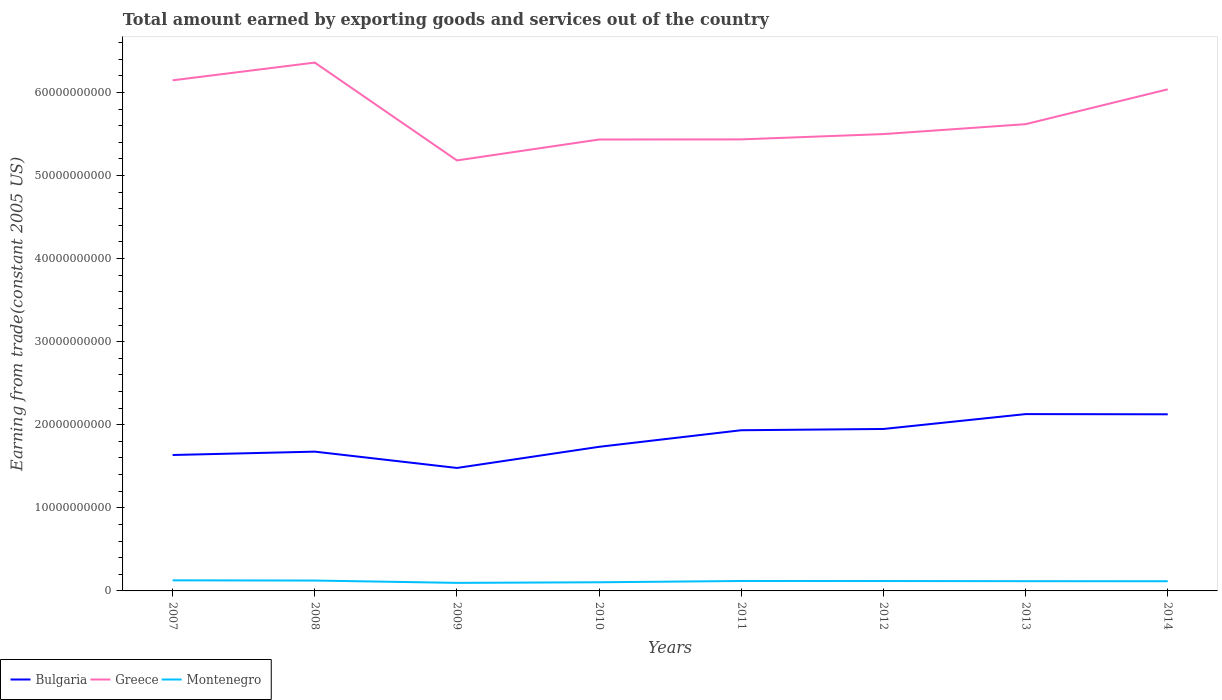Is the number of lines equal to the number of legend labels?
Provide a short and direct response. Yes. Across all years, what is the maximum total amount earned by exporting goods and services in Greece?
Your answer should be compact. 5.18e+1. In which year was the total amount earned by exporting goods and services in Bulgaria maximum?
Your response must be concise. 2009. What is the total total amount earned by exporting goods and services in Montenegro in the graph?
Keep it short and to the point. 2.61e+07. What is the difference between the highest and the second highest total amount earned by exporting goods and services in Greece?
Your answer should be very brief. 1.18e+1. Is the total amount earned by exporting goods and services in Montenegro strictly greater than the total amount earned by exporting goods and services in Greece over the years?
Provide a short and direct response. Yes. How many lines are there?
Ensure brevity in your answer.  3. How many years are there in the graph?
Your answer should be compact. 8. Are the values on the major ticks of Y-axis written in scientific E-notation?
Provide a succinct answer. No. Does the graph contain grids?
Keep it short and to the point. No. How many legend labels are there?
Offer a very short reply. 3. How are the legend labels stacked?
Your answer should be compact. Horizontal. What is the title of the graph?
Give a very brief answer. Total amount earned by exporting goods and services out of the country. What is the label or title of the X-axis?
Offer a terse response. Years. What is the label or title of the Y-axis?
Give a very brief answer. Earning from trade(constant 2005 US). What is the Earning from trade(constant 2005 US) in Bulgaria in 2007?
Ensure brevity in your answer.  1.64e+1. What is the Earning from trade(constant 2005 US) in Greece in 2007?
Keep it short and to the point. 6.15e+1. What is the Earning from trade(constant 2005 US) of Montenegro in 2007?
Ensure brevity in your answer.  1.27e+09. What is the Earning from trade(constant 2005 US) in Bulgaria in 2008?
Offer a terse response. 1.68e+1. What is the Earning from trade(constant 2005 US) of Greece in 2008?
Give a very brief answer. 6.36e+1. What is the Earning from trade(constant 2005 US) in Montenegro in 2008?
Your answer should be compact. 1.25e+09. What is the Earning from trade(constant 2005 US) in Bulgaria in 2009?
Provide a succinct answer. 1.48e+1. What is the Earning from trade(constant 2005 US) in Greece in 2009?
Offer a very short reply. 5.18e+1. What is the Earning from trade(constant 2005 US) in Montenegro in 2009?
Provide a short and direct response. 9.69e+08. What is the Earning from trade(constant 2005 US) of Bulgaria in 2010?
Provide a succinct answer. 1.73e+1. What is the Earning from trade(constant 2005 US) in Greece in 2010?
Your answer should be very brief. 5.43e+1. What is the Earning from trade(constant 2005 US) of Montenegro in 2010?
Ensure brevity in your answer.  1.04e+09. What is the Earning from trade(constant 2005 US) in Bulgaria in 2011?
Your answer should be compact. 1.93e+1. What is the Earning from trade(constant 2005 US) of Greece in 2011?
Your answer should be very brief. 5.44e+1. What is the Earning from trade(constant 2005 US) of Montenegro in 2011?
Your response must be concise. 1.19e+09. What is the Earning from trade(constant 2005 US) in Bulgaria in 2012?
Make the answer very short. 1.95e+1. What is the Earning from trade(constant 2005 US) in Greece in 2012?
Your answer should be very brief. 5.50e+1. What is the Earning from trade(constant 2005 US) in Montenegro in 2012?
Provide a succinct answer. 1.19e+09. What is the Earning from trade(constant 2005 US) in Bulgaria in 2013?
Keep it short and to the point. 2.13e+1. What is the Earning from trade(constant 2005 US) in Greece in 2013?
Offer a terse response. 5.62e+1. What is the Earning from trade(constant 2005 US) in Montenegro in 2013?
Your answer should be compact. 1.17e+09. What is the Earning from trade(constant 2005 US) of Bulgaria in 2014?
Provide a short and direct response. 2.13e+1. What is the Earning from trade(constant 2005 US) of Greece in 2014?
Keep it short and to the point. 6.04e+1. What is the Earning from trade(constant 2005 US) in Montenegro in 2014?
Your answer should be compact. 1.17e+09. Across all years, what is the maximum Earning from trade(constant 2005 US) in Bulgaria?
Provide a succinct answer. 2.13e+1. Across all years, what is the maximum Earning from trade(constant 2005 US) of Greece?
Your answer should be very brief. 6.36e+1. Across all years, what is the maximum Earning from trade(constant 2005 US) of Montenegro?
Provide a short and direct response. 1.27e+09. Across all years, what is the minimum Earning from trade(constant 2005 US) in Bulgaria?
Your response must be concise. 1.48e+1. Across all years, what is the minimum Earning from trade(constant 2005 US) in Greece?
Offer a very short reply. 5.18e+1. Across all years, what is the minimum Earning from trade(constant 2005 US) of Montenegro?
Your answer should be compact. 9.69e+08. What is the total Earning from trade(constant 2005 US) in Bulgaria in the graph?
Ensure brevity in your answer.  1.47e+11. What is the total Earning from trade(constant 2005 US) of Greece in the graph?
Keep it short and to the point. 4.57e+11. What is the total Earning from trade(constant 2005 US) of Montenegro in the graph?
Give a very brief answer. 9.26e+09. What is the difference between the Earning from trade(constant 2005 US) in Bulgaria in 2007 and that in 2008?
Your response must be concise. -4.05e+08. What is the difference between the Earning from trade(constant 2005 US) of Greece in 2007 and that in 2008?
Ensure brevity in your answer.  -2.13e+09. What is the difference between the Earning from trade(constant 2005 US) in Montenegro in 2007 and that in 2008?
Ensure brevity in your answer.  2.61e+07. What is the difference between the Earning from trade(constant 2005 US) in Bulgaria in 2007 and that in 2009?
Provide a succinct answer. 1.56e+09. What is the difference between the Earning from trade(constant 2005 US) of Greece in 2007 and that in 2009?
Make the answer very short. 9.64e+09. What is the difference between the Earning from trade(constant 2005 US) in Montenegro in 2007 and that in 2009?
Your answer should be compact. 3.05e+08. What is the difference between the Earning from trade(constant 2005 US) in Bulgaria in 2007 and that in 2010?
Provide a short and direct response. -9.86e+08. What is the difference between the Earning from trade(constant 2005 US) in Greece in 2007 and that in 2010?
Your answer should be very brief. 7.12e+09. What is the difference between the Earning from trade(constant 2005 US) in Montenegro in 2007 and that in 2010?
Your answer should be very brief. 2.32e+08. What is the difference between the Earning from trade(constant 2005 US) in Bulgaria in 2007 and that in 2011?
Give a very brief answer. -2.98e+09. What is the difference between the Earning from trade(constant 2005 US) of Greece in 2007 and that in 2011?
Provide a succinct answer. 7.11e+09. What is the difference between the Earning from trade(constant 2005 US) in Montenegro in 2007 and that in 2011?
Provide a short and direct response. 8.01e+07. What is the difference between the Earning from trade(constant 2005 US) of Bulgaria in 2007 and that in 2012?
Offer a very short reply. -3.13e+09. What is the difference between the Earning from trade(constant 2005 US) of Greece in 2007 and that in 2012?
Offer a terse response. 6.47e+09. What is the difference between the Earning from trade(constant 2005 US) in Montenegro in 2007 and that in 2012?
Offer a terse response. 8.41e+07. What is the difference between the Earning from trade(constant 2005 US) in Bulgaria in 2007 and that in 2013?
Your response must be concise. -4.92e+09. What is the difference between the Earning from trade(constant 2005 US) in Greece in 2007 and that in 2013?
Your answer should be very brief. 5.28e+09. What is the difference between the Earning from trade(constant 2005 US) of Montenegro in 2007 and that in 2013?
Your answer should be compact. 1.00e+08. What is the difference between the Earning from trade(constant 2005 US) of Bulgaria in 2007 and that in 2014?
Give a very brief answer. -4.90e+09. What is the difference between the Earning from trade(constant 2005 US) in Greece in 2007 and that in 2014?
Your answer should be compact. 1.08e+09. What is the difference between the Earning from trade(constant 2005 US) in Montenegro in 2007 and that in 2014?
Offer a terse response. 1.08e+08. What is the difference between the Earning from trade(constant 2005 US) of Bulgaria in 2008 and that in 2009?
Offer a terse response. 1.96e+09. What is the difference between the Earning from trade(constant 2005 US) of Greece in 2008 and that in 2009?
Provide a succinct answer. 1.18e+1. What is the difference between the Earning from trade(constant 2005 US) in Montenegro in 2008 and that in 2009?
Make the answer very short. 2.79e+08. What is the difference between the Earning from trade(constant 2005 US) of Bulgaria in 2008 and that in 2010?
Your answer should be compact. -5.80e+08. What is the difference between the Earning from trade(constant 2005 US) of Greece in 2008 and that in 2010?
Provide a succinct answer. 9.26e+09. What is the difference between the Earning from trade(constant 2005 US) in Montenegro in 2008 and that in 2010?
Your answer should be very brief. 2.06e+08. What is the difference between the Earning from trade(constant 2005 US) of Bulgaria in 2008 and that in 2011?
Keep it short and to the point. -2.58e+09. What is the difference between the Earning from trade(constant 2005 US) of Greece in 2008 and that in 2011?
Give a very brief answer. 9.24e+09. What is the difference between the Earning from trade(constant 2005 US) in Montenegro in 2008 and that in 2011?
Ensure brevity in your answer.  5.40e+07. What is the difference between the Earning from trade(constant 2005 US) of Bulgaria in 2008 and that in 2012?
Provide a short and direct response. -2.73e+09. What is the difference between the Earning from trade(constant 2005 US) of Greece in 2008 and that in 2012?
Your answer should be very brief. 8.61e+09. What is the difference between the Earning from trade(constant 2005 US) in Montenegro in 2008 and that in 2012?
Make the answer very short. 5.80e+07. What is the difference between the Earning from trade(constant 2005 US) in Bulgaria in 2008 and that in 2013?
Provide a succinct answer. -4.52e+09. What is the difference between the Earning from trade(constant 2005 US) in Greece in 2008 and that in 2013?
Offer a terse response. 7.41e+09. What is the difference between the Earning from trade(constant 2005 US) in Montenegro in 2008 and that in 2013?
Your answer should be very brief. 7.40e+07. What is the difference between the Earning from trade(constant 2005 US) in Bulgaria in 2008 and that in 2014?
Provide a succinct answer. -4.49e+09. What is the difference between the Earning from trade(constant 2005 US) in Greece in 2008 and that in 2014?
Keep it short and to the point. 3.22e+09. What is the difference between the Earning from trade(constant 2005 US) of Montenegro in 2008 and that in 2014?
Offer a very short reply. 8.24e+07. What is the difference between the Earning from trade(constant 2005 US) of Bulgaria in 2009 and that in 2010?
Provide a short and direct response. -2.54e+09. What is the difference between the Earning from trade(constant 2005 US) in Greece in 2009 and that in 2010?
Provide a short and direct response. -2.52e+09. What is the difference between the Earning from trade(constant 2005 US) in Montenegro in 2009 and that in 2010?
Give a very brief answer. -7.26e+07. What is the difference between the Earning from trade(constant 2005 US) of Bulgaria in 2009 and that in 2011?
Make the answer very short. -4.54e+09. What is the difference between the Earning from trade(constant 2005 US) of Greece in 2009 and that in 2011?
Make the answer very short. -2.53e+09. What is the difference between the Earning from trade(constant 2005 US) of Montenegro in 2009 and that in 2011?
Ensure brevity in your answer.  -2.25e+08. What is the difference between the Earning from trade(constant 2005 US) of Bulgaria in 2009 and that in 2012?
Keep it short and to the point. -4.69e+09. What is the difference between the Earning from trade(constant 2005 US) of Greece in 2009 and that in 2012?
Ensure brevity in your answer.  -3.17e+09. What is the difference between the Earning from trade(constant 2005 US) of Montenegro in 2009 and that in 2012?
Offer a terse response. -2.21e+08. What is the difference between the Earning from trade(constant 2005 US) in Bulgaria in 2009 and that in 2013?
Make the answer very short. -6.48e+09. What is the difference between the Earning from trade(constant 2005 US) of Greece in 2009 and that in 2013?
Keep it short and to the point. -4.36e+09. What is the difference between the Earning from trade(constant 2005 US) of Montenegro in 2009 and that in 2013?
Provide a short and direct response. -2.05e+08. What is the difference between the Earning from trade(constant 2005 US) in Bulgaria in 2009 and that in 2014?
Your response must be concise. -6.46e+09. What is the difference between the Earning from trade(constant 2005 US) of Greece in 2009 and that in 2014?
Provide a succinct answer. -8.56e+09. What is the difference between the Earning from trade(constant 2005 US) of Montenegro in 2009 and that in 2014?
Your response must be concise. -1.97e+08. What is the difference between the Earning from trade(constant 2005 US) in Bulgaria in 2010 and that in 2011?
Ensure brevity in your answer.  -2.00e+09. What is the difference between the Earning from trade(constant 2005 US) of Greece in 2010 and that in 2011?
Your response must be concise. -1.48e+07. What is the difference between the Earning from trade(constant 2005 US) of Montenegro in 2010 and that in 2011?
Your response must be concise. -1.52e+08. What is the difference between the Earning from trade(constant 2005 US) of Bulgaria in 2010 and that in 2012?
Keep it short and to the point. -2.15e+09. What is the difference between the Earning from trade(constant 2005 US) in Greece in 2010 and that in 2012?
Your answer should be very brief. -6.52e+08. What is the difference between the Earning from trade(constant 2005 US) of Montenegro in 2010 and that in 2012?
Your response must be concise. -1.48e+08. What is the difference between the Earning from trade(constant 2005 US) in Bulgaria in 2010 and that in 2013?
Your response must be concise. -3.94e+09. What is the difference between the Earning from trade(constant 2005 US) in Greece in 2010 and that in 2013?
Give a very brief answer. -1.85e+09. What is the difference between the Earning from trade(constant 2005 US) in Montenegro in 2010 and that in 2013?
Make the answer very short. -1.32e+08. What is the difference between the Earning from trade(constant 2005 US) of Bulgaria in 2010 and that in 2014?
Provide a succinct answer. -3.91e+09. What is the difference between the Earning from trade(constant 2005 US) of Greece in 2010 and that in 2014?
Offer a very short reply. -6.04e+09. What is the difference between the Earning from trade(constant 2005 US) of Montenegro in 2010 and that in 2014?
Your answer should be very brief. -1.24e+08. What is the difference between the Earning from trade(constant 2005 US) of Bulgaria in 2011 and that in 2012?
Your answer should be very brief. -1.51e+08. What is the difference between the Earning from trade(constant 2005 US) of Greece in 2011 and that in 2012?
Offer a terse response. -6.38e+08. What is the difference between the Earning from trade(constant 2005 US) of Montenegro in 2011 and that in 2012?
Offer a very short reply. 4.06e+06. What is the difference between the Earning from trade(constant 2005 US) of Bulgaria in 2011 and that in 2013?
Give a very brief answer. -1.94e+09. What is the difference between the Earning from trade(constant 2005 US) in Greece in 2011 and that in 2013?
Provide a short and direct response. -1.83e+09. What is the difference between the Earning from trade(constant 2005 US) in Montenegro in 2011 and that in 2013?
Your answer should be very brief. 2.00e+07. What is the difference between the Earning from trade(constant 2005 US) in Bulgaria in 2011 and that in 2014?
Your answer should be very brief. -1.92e+09. What is the difference between the Earning from trade(constant 2005 US) in Greece in 2011 and that in 2014?
Keep it short and to the point. -6.02e+09. What is the difference between the Earning from trade(constant 2005 US) in Montenegro in 2011 and that in 2014?
Your answer should be compact. 2.84e+07. What is the difference between the Earning from trade(constant 2005 US) of Bulgaria in 2012 and that in 2013?
Your response must be concise. -1.79e+09. What is the difference between the Earning from trade(constant 2005 US) in Greece in 2012 and that in 2013?
Give a very brief answer. -1.19e+09. What is the difference between the Earning from trade(constant 2005 US) of Montenegro in 2012 and that in 2013?
Keep it short and to the point. 1.59e+07. What is the difference between the Earning from trade(constant 2005 US) of Bulgaria in 2012 and that in 2014?
Make the answer very short. -1.77e+09. What is the difference between the Earning from trade(constant 2005 US) in Greece in 2012 and that in 2014?
Ensure brevity in your answer.  -5.39e+09. What is the difference between the Earning from trade(constant 2005 US) in Montenegro in 2012 and that in 2014?
Offer a very short reply. 2.43e+07. What is the difference between the Earning from trade(constant 2005 US) of Bulgaria in 2013 and that in 2014?
Provide a succinct answer. 2.37e+07. What is the difference between the Earning from trade(constant 2005 US) of Greece in 2013 and that in 2014?
Give a very brief answer. -4.19e+09. What is the difference between the Earning from trade(constant 2005 US) of Montenegro in 2013 and that in 2014?
Offer a very short reply. 8.40e+06. What is the difference between the Earning from trade(constant 2005 US) of Bulgaria in 2007 and the Earning from trade(constant 2005 US) of Greece in 2008?
Offer a terse response. -4.72e+1. What is the difference between the Earning from trade(constant 2005 US) in Bulgaria in 2007 and the Earning from trade(constant 2005 US) in Montenegro in 2008?
Keep it short and to the point. 1.51e+1. What is the difference between the Earning from trade(constant 2005 US) in Greece in 2007 and the Earning from trade(constant 2005 US) in Montenegro in 2008?
Keep it short and to the point. 6.02e+1. What is the difference between the Earning from trade(constant 2005 US) of Bulgaria in 2007 and the Earning from trade(constant 2005 US) of Greece in 2009?
Keep it short and to the point. -3.55e+1. What is the difference between the Earning from trade(constant 2005 US) of Bulgaria in 2007 and the Earning from trade(constant 2005 US) of Montenegro in 2009?
Ensure brevity in your answer.  1.54e+1. What is the difference between the Earning from trade(constant 2005 US) in Greece in 2007 and the Earning from trade(constant 2005 US) in Montenegro in 2009?
Ensure brevity in your answer.  6.05e+1. What is the difference between the Earning from trade(constant 2005 US) in Bulgaria in 2007 and the Earning from trade(constant 2005 US) in Greece in 2010?
Provide a succinct answer. -3.80e+1. What is the difference between the Earning from trade(constant 2005 US) of Bulgaria in 2007 and the Earning from trade(constant 2005 US) of Montenegro in 2010?
Keep it short and to the point. 1.53e+1. What is the difference between the Earning from trade(constant 2005 US) of Greece in 2007 and the Earning from trade(constant 2005 US) of Montenegro in 2010?
Your answer should be compact. 6.04e+1. What is the difference between the Earning from trade(constant 2005 US) in Bulgaria in 2007 and the Earning from trade(constant 2005 US) in Greece in 2011?
Offer a very short reply. -3.80e+1. What is the difference between the Earning from trade(constant 2005 US) of Bulgaria in 2007 and the Earning from trade(constant 2005 US) of Montenegro in 2011?
Provide a short and direct response. 1.52e+1. What is the difference between the Earning from trade(constant 2005 US) of Greece in 2007 and the Earning from trade(constant 2005 US) of Montenegro in 2011?
Your response must be concise. 6.03e+1. What is the difference between the Earning from trade(constant 2005 US) in Bulgaria in 2007 and the Earning from trade(constant 2005 US) in Greece in 2012?
Your answer should be compact. -3.86e+1. What is the difference between the Earning from trade(constant 2005 US) in Bulgaria in 2007 and the Earning from trade(constant 2005 US) in Montenegro in 2012?
Your answer should be compact. 1.52e+1. What is the difference between the Earning from trade(constant 2005 US) in Greece in 2007 and the Earning from trade(constant 2005 US) in Montenegro in 2012?
Your answer should be very brief. 6.03e+1. What is the difference between the Earning from trade(constant 2005 US) of Bulgaria in 2007 and the Earning from trade(constant 2005 US) of Greece in 2013?
Offer a terse response. -3.98e+1. What is the difference between the Earning from trade(constant 2005 US) of Bulgaria in 2007 and the Earning from trade(constant 2005 US) of Montenegro in 2013?
Provide a short and direct response. 1.52e+1. What is the difference between the Earning from trade(constant 2005 US) in Greece in 2007 and the Earning from trade(constant 2005 US) in Montenegro in 2013?
Offer a terse response. 6.03e+1. What is the difference between the Earning from trade(constant 2005 US) in Bulgaria in 2007 and the Earning from trade(constant 2005 US) in Greece in 2014?
Provide a short and direct response. -4.40e+1. What is the difference between the Earning from trade(constant 2005 US) in Bulgaria in 2007 and the Earning from trade(constant 2005 US) in Montenegro in 2014?
Provide a short and direct response. 1.52e+1. What is the difference between the Earning from trade(constant 2005 US) in Greece in 2007 and the Earning from trade(constant 2005 US) in Montenegro in 2014?
Ensure brevity in your answer.  6.03e+1. What is the difference between the Earning from trade(constant 2005 US) of Bulgaria in 2008 and the Earning from trade(constant 2005 US) of Greece in 2009?
Keep it short and to the point. -3.51e+1. What is the difference between the Earning from trade(constant 2005 US) of Bulgaria in 2008 and the Earning from trade(constant 2005 US) of Montenegro in 2009?
Keep it short and to the point. 1.58e+1. What is the difference between the Earning from trade(constant 2005 US) of Greece in 2008 and the Earning from trade(constant 2005 US) of Montenegro in 2009?
Your response must be concise. 6.26e+1. What is the difference between the Earning from trade(constant 2005 US) in Bulgaria in 2008 and the Earning from trade(constant 2005 US) in Greece in 2010?
Give a very brief answer. -3.76e+1. What is the difference between the Earning from trade(constant 2005 US) in Bulgaria in 2008 and the Earning from trade(constant 2005 US) in Montenegro in 2010?
Ensure brevity in your answer.  1.57e+1. What is the difference between the Earning from trade(constant 2005 US) in Greece in 2008 and the Earning from trade(constant 2005 US) in Montenegro in 2010?
Offer a very short reply. 6.26e+1. What is the difference between the Earning from trade(constant 2005 US) in Bulgaria in 2008 and the Earning from trade(constant 2005 US) in Greece in 2011?
Your answer should be very brief. -3.76e+1. What is the difference between the Earning from trade(constant 2005 US) in Bulgaria in 2008 and the Earning from trade(constant 2005 US) in Montenegro in 2011?
Offer a terse response. 1.56e+1. What is the difference between the Earning from trade(constant 2005 US) in Greece in 2008 and the Earning from trade(constant 2005 US) in Montenegro in 2011?
Make the answer very short. 6.24e+1. What is the difference between the Earning from trade(constant 2005 US) in Bulgaria in 2008 and the Earning from trade(constant 2005 US) in Greece in 2012?
Provide a short and direct response. -3.82e+1. What is the difference between the Earning from trade(constant 2005 US) of Bulgaria in 2008 and the Earning from trade(constant 2005 US) of Montenegro in 2012?
Make the answer very short. 1.56e+1. What is the difference between the Earning from trade(constant 2005 US) of Greece in 2008 and the Earning from trade(constant 2005 US) of Montenegro in 2012?
Offer a very short reply. 6.24e+1. What is the difference between the Earning from trade(constant 2005 US) of Bulgaria in 2008 and the Earning from trade(constant 2005 US) of Greece in 2013?
Provide a short and direct response. -3.94e+1. What is the difference between the Earning from trade(constant 2005 US) in Bulgaria in 2008 and the Earning from trade(constant 2005 US) in Montenegro in 2013?
Ensure brevity in your answer.  1.56e+1. What is the difference between the Earning from trade(constant 2005 US) in Greece in 2008 and the Earning from trade(constant 2005 US) in Montenegro in 2013?
Your response must be concise. 6.24e+1. What is the difference between the Earning from trade(constant 2005 US) in Bulgaria in 2008 and the Earning from trade(constant 2005 US) in Greece in 2014?
Keep it short and to the point. -4.36e+1. What is the difference between the Earning from trade(constant 2005 US) of Bulgaria in 2008 and the Earning from trade(constant 2005 US) of Montenegro in 2014?
Your answer should be compact. 1.56e+1. What is the difference between the Earning from trade(constant 2005 US) in Greece in 2008 and the Earning from trade(constant 2005 US) in Montenegro in 2014?
Offer a terse response. 6.24e+1. What is the difference between the Earning from trade(constant 2005 US) in Bulgaria in 2009 and the Earning from trade(constant 2005 US) in Greece in 2010?
Keep it short and to the point. -3.95e+1. What is the difference between the Earning from trade(constant 2005 US) in Bulgaria in 2009 and the Earning from trade(constant 2005 US) in Montenegro in 2010?
Make the answer very short. 1.38e+1. What is the difference between the Earning from trade(constant 2005 US) of Greece in 2009 and the Earning from trade(constant 2005 US) of Montenegro in 2010?
Keep it short and to the point. 5.08e+1. What is the difference between the Earning from trade(constant 2005 US) in Bulgaria in 2009 and the Earning from trade(constant 2005 US) in Greece in 2011?
Provide a short and direct response. -3.95e+1. What is the difference between the Earning from trade(constant 2005 US) in Bulgaria in 2009 and the Earning from trade(constant 2005 US) in Montenegro in 2011?
Offer a terse response. 1.36e+1. What is the difference between the Earning from trade(constant 2005 US) of Greece in 2009 and the Earning from trade(constant 2005 US) of Montenegro in 2011?
Your response must be concise. 5.06e+1. What is the difference between the Earning from trade(constant 2005 US) of Bulgaria in 2009 and the Earning from trade(constant 2005 US) of Greece in 2012?
Offer a terse response. -4.02e+1. What is the difference between the Earning from trade(constant 2005 US) of Bulgaria in 2009 and the Earning from trade(constant 2005 US) of Montenegro in 2012?
Your answer should be very brief. 1.36e+1. What is the difference between the Earning from trade(constant 2005 US) of Greece in 2009 and the Earning from trade(constant 2005 US) of Montenegro in 2012?
Your response must be concise. 5.06e+1. What is the difference between the Earning from trade(constant 2005 US) in Bulgaria in 2009 and the Earning from trade(constant 2005 US) in Greece in 2013?
Make the answer very short. -4.14e+1. What is the difference between the Earning from trade(constant 2005 US) in Bulgaria in 2009 and the Earning from trade(constant 2005 US) in Montenegro in 2013?
Make the answer very short. 1.36e+1. What is the difference between the Earning from trade(constant 2005 US) in Greece in 2009 and the Earning from trade(constant 2005 US) in Montenegro in 2013?
Offer a very short reply. 5.06e+1. What is the difference between the Earning from trade(constant 2005 US) in Bulgaria in 2009 and the Earning from trade(constant 2005 US) in Greece in 2014?
Offer a very short reply. -4.56e+1. What is the difference between the Earning from trade(constant 2005 US) of Bulgaria in 2009 and the Earning from trade(constant 2005 US) of Montenegro in 2014?
Your response must be concise. 1.36e+1. What is the difference between the Earning from trade(constant 2005 US) in Greece in 2009 and the Earning from trade(constant 2005 US) in Montenegro in 2014?
Keep it short and to the point. 5.07e+1. What is the difference between the Earning from trade(constant 2005 US) of Bulgaria in 2010 and the Earning from trade(constant 2005 US) of Greece in 2011?
Provide a short and direct response. -3.70e+1. What is the difference between the Earning from trade(constant 2005 US) in Bulgaria in 2010 and the Earning from trade(constant 2005 US) in Montenegro in 2011?
Your answer should be very brief. 1.62e+1. What is the difference between the Earning from trade(constant 2005 US) in Greece in 2010 and the Earning from trade(constant 2005 US) in Montenegro in 2011?
Offer a terse response. 5.31e+1. What is the difference between the Earning from trade(constant 2005 US) in Bulgaria in 2010 and the Earning from trade(constant 2005 US) in Greece in 2012?
Ensure brevity in your answer.  -3.76e+1. What is the difference between the Earning from trade(constant 2005 US) of Bulgaria in 2010 and the Earning from trade(constant 2005 US) of Montenegro in 2012?
Ensure brevity in your answer.  1.62e+1. What is the difference between the Earning from trade(constant 2005 US) in Greece in 2010 and the Earning from trade(constant 2005 US) in Montenegro in 2012?
Your response must be concise. 5.31e+1. What is the difference between the Earning from trade(constant 2005 US) in Bulgaria in 2010 and the Earning from trade(constant 2005 US) in Greece in 2013?
Your response must be concise. -3.88e+1. What is the difference between the Earning from trade(constant 2005 US) in Bulgaria in 2010 and the Earning from trade(constant 2005 US) in Montenegro in 2013?
Offer a very short reply. 1.62e+1. What is the difference between the Earning from trade(constant 2005 US) in Greece in 2010 and the Earning from trade(constant 2005 US) in Montenegro in 2013?
Your response must be concise. 5.32e+1. What is the difference between the Earning from trade(constant 2005 US) of Bulgaria in 2010 and the Earning from trade(constant 2005 US) of Greece in 2014?
Provide a short and direct response. -4.30e+1. What is the difference between the Earning from trade(constant 2005 US) in Bulgaria in 2010 and the Earning from trade(constant 2005 US) in Montenegro in 2014?
Make the answer very short. 1.62e+1. What is the difference between the Earning from trade(constant 2005 US) in Greece in 2010 and the Earning from trade(constant 2005 US) in Montenegro in 2014?
Keep it short and to the point. 5.32e+1. What is the difference between the Earning from trade(constant 2005 US) in Bulgaria in 2011 and the Earning from trade(constant 2005 US) in Greece in 2012?
Keep it short and to the point. -3.56e+1. What is the difference between the Earning from trade(constant 2005 US) of Bulgaria in 2011 and the Earning from trade(constant 2005 US) of Montenegro in 2012?
Offer a very short reply. 1.82e+1. What is the difference between the Earning from trade(constant 2005 US) of Greece in 2011 and the Earning from trade(constant 2005 US) of Montenegro in 2012?
Offer a very short reply. 5.32e+1. What is the difference between the Earning from trade(constant 2005 US) of Bulgaria in 2011 and the Earning from trade(constant 2005 US) of Greece in 2013?
Your response must be concise. -3.68e+1. What is the difference between the Earning from trade(constant 2005 US) of Bulgaria in 2011 and the Earning from trade(constant 2005 US) of Montenegro in 2013?
Offer a terse response. 1.82e+1. What is the difference between the Earning from trade(constant 2005 US) in Greece in 2011 and the Earning from trade(constant 2005 US) in Montenegro in 2013?
Your response must be concise. 5.32e+1. What is the difference between the Earning from trade(constant 2005 US) in Bulgaria in 2011 and the Earning from trade(constant 2005 US) in Greece in 2014?
Provide a succinct answer. -4.10e+1. What is the difference between the Earning from trade(constant 2005 US) in Bulgaria in 2011 and the Earning from trade(constant 2005 US) in Montenegro in 2014?
Offer a very short reply. 1.82e+1. What is the difference between the Earning from trade(constant 2005 US) in Greece in 2011 and the Earning from trade(constant 2005 US) in Montenegro in 2014?
Provide a short and direct response. 5.32e+1. What is the difference between the Earning from trade(constant 2005 US) in Bulgaria in 2012 and the Earning from trade(constant 2005 US) in Greece in 2013?
Give a very brief answer. -3.67e+1. What is the difference between the Earning from trade(constant 2005 US) of Bulgaria in 2012 and the Earning from trade(constant 2005 US) of Montenegro in 2013?
Keep it short and to the point. 1.83e+1. What is the difference between the Earning from trade(constant 2005 US) of Greece in 2012 and the Earning from trade(constant 2005 US) of Montenegro in 2013?
Ensure brevity in your answer.  5.38e+1. What is the difference between the Earning from trade(constant 2005 US) of Bulgaria in 2012 and the Earning from trade(constant 2005 US) of Greece in 2014?
Offer a terse response. -4.09e+1. What is the difference between the Earning from trade(constant 2005 US) of Bulgaria in 2012 and the Earning from trade(constant 2005 US) of Montenegro in 2014?
Your response must be concise. 1.83e+1. What is the difference between the Earning from trade(constant 2005 US) of Greece in 2012 and the Earning from trade(constant 2005 US) of Montenegro in 2014?
Ensure brevity in your answer.  5.38e+1. What is the difference between the Earning from trade(constant 2005 US) of Bulgaria in 2013 and the Earning from trade(constant 2005 US) of Greece in 2014?
Your answer should be compact. -3.91e+1. What is the difference between the Earning from trade(constant 2005 US) of Bulgaria in 2013 and the Earning from trade(constant 2005 US) of Montenegro in 2014?
Provide a short and direct response. 2.01e+1. What is the difference between the Earning from trade(constant 2005 US) of Greece in 2013 and the Earning from trade(constant 2005 US) of Montenegro in 2014?
Offer a very short reply. 5.50e+1. What is the average Earning from trade(constant 2005 US) of Bulgaria per year?
Provide a succinct answer. 1.83e+1. What is the average Earning from trade(constant 2005 US) of Greece per year?
Your response must be concise. 5.71e+1. What is the average Earning from trade(constant 2005 US) of Montenegro per year?
Keep it short and to the point. 1.16e+09. In the year 2007, what is the difference between the Earning from trade(constant 2005 US) of Bulgaria and Earning from trade(constant 2005 US) of Greece?
Keep it short and to the point. -4.51e+1. In the year 2007, what is the difference between the Earning from trade(constant 2005 US) of Bulgaria and Earning from trade(constant 2005 US) of Montenegro?
Give a very brief answer. 1.51e+1. In the year 2007, what is the difference between the Earning from trade(constant 2005 US) of Greece and Earning from trade(constant 2005 US) of Montenegro?
Provide a short and direct response. 6.02e+1. In the year 2008, what is the difference between the Earning from trade(constant 2005 US) in Bulgaria and Earning from trade(constant 2005 US) in Greece?
Keep it short and to the point. -4.68e+1. In the year 2008, what is the difference between the Earning from trade(constant 2005 US) of Bulgaria and Earning from trade(constant 2005 US) of Montenegro?
Your response must be concise. 1.55e+1. In the year 2008, what is the difference between the Earning from trade(constant 2005 US) of Greece and Earning from trade(constant 2005 US) of Montenegro?
Give a very brief answer. 6.23e+1. In the year 2009, what is the difference between the Earning from trade(constant 2005 US) of Bulgaria and Earning from trade(constant 2005 US) of Greece?
Ensure brevity in your answer.  -3.70e+1. In the year 2009, what is the difference between the Earning from trade(constant 2005 US) in Bulgaria and Earning from trade(constant 2005 US) in Montenegro?
Your response must be concise. 1.38e+1. In the year 2009, what is the difference between the Earning from trade(constant 2005 US) in Greece and Earning from trade(constant 2005 US) in Montenegro?
Your answer should be very brief. 5.08e+1. In the year 2010, what is the difference between the Earning from trade(constant 2005 US) in Bulgaria and Earning from trade(constant 2005 US) in Greece?
Provide a short and direct response. -3.70e+1. In the year 2010, what is the difference between the Earning from trade(constant 2005 US) of Bulgaria and Earning from trade(constant 2005 US) of Montenegro?
Offer a terse response. 1.63e+1. In the year 2010, what is the difference between the Earning from trade(constant 2005 US) in Greece and Earning from trade(constant 2005 US) in Montenegro?
Your answer should be very brief. 5.33e+1. In the year 2011, what is the difference between the Earning from trade(constant 2005 US) of Bulgaria and Earning from trade(constant 2005 US) of Greece?
Offer a very short reply. -3.50e+1. In the year 2011, what is the difference between the Earning from trade(constant 2005 US) of Bulgaria and Earning from trade(constant 2005 US) of Montenegro?
Give a very brief answer. 1.81e+1. In the year 2011, what is the difference between the Earning from trade(constant 2005 US) of Greece and Earning from trade(constant 2005 US) of Montenegro?
Provide a short and direct response. 5.32e+1. In the year 2012, what is the difference between the Earning from trade(constant 2005 US) of Bulgaria and Earning from trade(constant 2005 US) of Greece?
Provide a succinct answer. -3.55e+1. In the year 2012, what is the difference between the Earning from trade(constant 2005 US) of Bulgaria and Earning from trade(constant 2005 US) of Montenegro?
Provide a succinct answer. 1.83e+1. In the year 2012, what is the difference between the Earning from trade(constant 2005 US) in Greece and Earning from trade(constant 2005 US) in Montenegro?
Ensure brevity in your answer.  5.38e+1. In the year 2013, what is the difference between the Earning from trade(constant 2005 US) in Bulgaria and Earning from trade(constant 2005 US) in Greece?
Keep it short and to the point. -3.49e+1. In the year 2013, what is the difference between the Earning from trade(constant 2005 US) in Bulgaria and Earning from trade(constant 2005 US) in Montenegro?
Offer a very short reply. 2.01e+1. In the year 2013, what is the difference between the Earning from trade(constant 2005 US) in Greece and Earning from trade(constant 2005 US) in Montenegro?
Offer a very short reply. 5.50e+1. In the year 2014, what is the difference between the Earning from trade(constant 2005 US) of Bulgaria and Earning from trade(constant 2005 US) of Greece?
Make the answer very short. -3.91e+1. In the year 2014, what is the difference between the Earning from trade(constant 2005 US) of Bulgaria and Earning from trade(constant 2005 US) of Montenegro?
Your answer should be compact. 2.01e+1. In the year 2014, what is the difference between the Earning from trade(constant 2005 US) of Greece and Earning from trade(constant 2005 US) of Montenegro?
Offer a terse response. 5.92e+1. What is the ratio of the Earning from trade(constant 2005 US) of Bulgaria in 2007 to that in 2008?
Offer a very short reply. 0.98. What is the ratio of the Earning from trade(constant 2005 US) in Greece in 2007 to that in 2008?
Provide a succinct answer. 0.97. What is the ratio of the Earning from trade(constant 2005 US) in Montenegro in 2007 to that in 2008?
Your answer should be very brief. 1.02. What is the ratio of the Earning from trade(constant 2005 US) of Bulgaria in 2007 to that in 2009?
Your answer should be compact. 1.11. What is the ratio of the Earning from trade(constant 2005 US) in Greece in 2007 to that in 2009?
Provide a short and direct response. 1.19. What is the ratio of the Earning from trade(constant 2005 US) in Montenegro in 2007 to that in 2009?
Give a very brief answer. 1.31. What is the ratio of the Earning from trade(constant 2005 US) of Bulgaria in 2007 to that in 2010?
Ensure brevity in your answer.  0.94. What is the ratio of the Earning from trade(constant 2005 US) of Greece in 2007 to that in 2010?
Provide a short and direct response. 1.13. What is the ratio of the Earning from trade(constant 2005 US) of Montenegro in 2007 to that in 2010?
Make the answer very short. 1.22. What is the ratio of the Earning from trade(constant 2005 US) of Bulgaria in 2007 to that in 2011?
Keep it short and to the point. 0.85. What is the ratio of the Earning from trade(constant 2005 US) of Greece in 2007 to that in 2011?
Provide a succinct answer. 1.13. What is the ratio of the Earning from trade(constant 2005 US) in Montenegro in 2007 to that in 2011?
Your response must be concise. 1.07. What is the ratio of the Earning from trade(constant 2005 US) in Bulgaria in 2007 to that in 2012?
Give a very brief answer. 0.84. What is the ratio of the Earning from trade(constant 2005 US) in Greece in 2007 to that in 2012?
Your response must be concise. 1.12. What is the ratio of the Earning from trade(constant 2005 US) in Montenegro in 2007 to that in 2012?
Offer a very short reply. 1.07. What is the ratio of the Earning from trade(constant 2005 US) of Bulgaria in 2007 to that in 2013?
Give a very brief answer. 0.77. What is the ratio of the Earning from trade(constant 2005 US) in Greece in 2007 to that in 2013?
Your answer should be very brief. 1.09. What is the ratio of the Earning from trade(constant 2005 US) in Montenegro in 2007 to that in 2013?
Provide a succinct answer. 1.09. What is the ratio of the Earning from trade(constant 2005 US) of Bulgaria in 2007 to that in 2014?
Offer a very short reply. 0.77. What is the ratio of the Earning from trade(constant 2005 US) in Greece in 2007 to that in 2014?
Make the answer very short. 1.02. What is the ratio of the Earning from trade(constant 2005 US) of Montenegro in 2007 to that in 2014?
Make the answer very short. 1.09. What is the ratio of the Earning from trade(constant 2005 US) of Bulgaria in 2008 to that in 2009?
Provide a succinct answer. 1.13. What is the ratio of the Earning from trade(constant 2005 US) in Greece in 2008 to that in 2009?
Your answer should be very brief. 1.23. What is the ratio of the Earning from trade(constant 2005 US) in Montenegro in 2008 to that in 2009?
Your answer should be very brief. 1.29. What is the ratio of the Earning from trade(constant 2005 US) of Bulgaria in 2008 to that in 2010?
Provide a short and direct response. 0.97. What is the ratio of the Earning from trade(constant 2005 US) in Greece in 2008 to that in 2010?
Ensure brevity in your answer.  1.17. What is the ratio of the Earning from trade(constant 2005 US) in Montenegro in 2008 to that in 2010?
Your answer should be very brief. 1.2. What is the ratio of the Earning from trade(constant 2005 US) in Bulgaria in 2008 to that in 2011?
Your answer should be very brief. 0.87. What is the ratio of the Earning from trade(constant 2005 US) of Greece in 2008 to that in 2011?
Offer a very short reply. 1.17. What is the ratio of the Earning from trade(constant 2005 US) in Montenegro in 2008 to that in 2011?
Make the answer very short. 1.05. What is the ratio of the Earning from trade(constant 2005 US) in Bulgaria in 2008 to that in 2012?
Make the answer very short. 0.86. What is the ratio of the Earning from trade(constant 2005 US) of Greece in 2008 to that in 2012?
Keep it short and to the point. 1.16. What is the ratio of the Earning from trade(constant 2005 US) in Montenegro in 2008 to that in 2012?
Your answer should be very brief. 1.05. What is the ratio of the Earning from trade(constant 2005 US) of Bulgaria in 2008 to that in 2013?
Ensure brevity in your answer.  0.79. What is the ratio of the Earning from trade(constant 2005 US) in Greece in 2008 to that in 2013?
Give a very brief answer. 1.13. What is the ratio of the Earning from trade(constant 2005 US) of Montenegro in 2008 to that in 2013?
Your answer should be very brief. 1.06. What is the ratio of the Earning from trade(constant 2005 US) in Bulgaria in 2008 to that in 2014?
Keep it short and to the point. 0.79. What is the ratio of the Earning from trade(constant 2005 US) of Greece in 2008 to that in 2014?
Give a very brief answer. 1.05. What is the ratio of the Earning from trade(constant 2005 US) in Montenegro in 2008 to that in 2014?
Your response must be concise. 1.07. What is the ratio of the Earning from trade(constant 2005 US) in Bulgaria in 2009 to that in 2010?
Your answer should be compact. 0.85. What is the ratio of the Earning from trade(constant 2005 US) in Greece in 2009 to that in 2010?
Your answer should be very brief. 0.95. What is the ratio of the Earning from trade(constant 2005 US) of Montenegro in 2009 to that in 2010?
Your answer should be very brief. 0.93. What is the ratio of the Earning from trade(constant 2005 US) in Bulgaria in 2009 to that in 2011?
Offer a terse response. 0.77. What is the ratio of the Earning from trade(constant 2005 US) of Greece in 2009 to that in 2011?
Your response must be concise. 0.95. What is the ratio of the Earning from trade(constant 2005 US) in Montenegro in 2009 to that in 2011?
Give a very brief answer. 0.81. What is the ratio of the Earning from trade(constant 2005 US) of Bulgaria in 2009 to that in 2012?
Ensure brevity in your answer.  0.76. What is the ratio of the Earning from trade(constant 2005 US) in Greece in 2009 to that in 2012?
Your answer should be very brief. 0.94. What is the ratio of the Earning from trade(constant 2005 US) of Montenegro in 2009 to that in 2012?
Give a very brief answer. 0.81. What is the ratio of the Earning from trade(constant 2005 US) in Bulgaria in 2009 to that in 2013?
Give a very brief answer. 0.7. What is the ratio of the Earning from trade(constant 2005 US) of Greece in 2009 to that in 2013?
Offer a terse response. 0.92. What is the ratio of the Earning from trade(constant 2005 US) in Montenegro in 2009 to that in 2013?
Your response must be concise. 0.83. What is the ratio of the Earning from trade(constant 2005 US) of Bulgaria in 2009 to that in 2014?
Keep it short and to the point. 0.7. What is the ratio of the Earning from trade(constant 2005 US) of Greece in 2009 to that in 2014?
Ensure brevity in your answer.  0.86. What is the ratio of the Earning from trade(constant 2005 US) of Montenegro in 2009 to that in 2014?
Provide a short and direct response. 0.83. What is the ratio of the Earning from trade(constant 2005 US) in Bulgaria in 2010 to that in 2011?
Offer a terse response. 0.9. What is the ratio of the Earning from trade(constant 2005 US) of Greece in 2010 to that in 2011?
Your response must be concise. 1. What is the ratio of the Earning from trade(constant 2005 US) of Montenegro in 2010 to that in 2011?
Offer a very short reply. 0.87. What is the ratio of the Earning from trade(constant 2005 US) in Bulgaria in 2010 to that in 2012?
Your answer should be compact. 0.89. What is the ratio of the Earning from trade(constant 2005 US) in Greece in 2010 to that in 2012?
Provide a short and direct response. 0.99. What is the ratio of the Earning from trade(constant 2005 US) of Montenegro in 2010 to that in 2012?
Provide a short and direct response. 0.88. What is the ratio of the Earning from trade(constant 2005 US) of Bulgaria in 2010 to that in 2013?
Make the answer very short. 0.81. What is the ratio of the Earning from trade(constant 2005 US) of Greece in 2010 to that in 2013?
Give a very brief answer. 0.97. What is the ratio of the Earning from trade(constant 2005 US) in Montenegro in 2010 to that in 2013?
Provide a short and direct response. 0.89. What is the ratio of the Earning from trade(constant 2005 US) in Bulgaria in 2010 to that in 2014?
Provide a succinct answer. 0.82. What is the ratio of the Earning from trade(constant 2005 US) in Greece in 2010 to that in 2014?
Your answer should be very brief. 0.9. What is the ratio of the Earning from trade(constant 2005 US) in Montenegro in 2010 to that in 2014?
Offer a terse response. 0.89. What is the ratio of the Earning from trade(constant 2005 US) in Greece in 2011 to that in 2012?
Provide a short and direct response. 0.99. What is the ratio of the Earning from trade(constant 2005 US) in Bulgaria in 2011 to that in 2013?
Make the answer very short. 0.91. What is the ratio of the Earning from trade(constant 2005 US) of Greece in 2011 to that in 2013?
Your response must be concise. 0.97. What is the ratio of the Earning from trade(constant 2005 US) in Bulgaria in 2011 to that in 2014?
Provide a short and direct response. 0.91. What is the ratio of the Earning from trade(constant 2005 US) in Greece in 2011 to that in 2014?
Offer a very short reply. 0.9. What is the ratio of the Earning from trade(constant 2005 US) of Montenegro in 2011 to that in 2014?
Ensure brevity in your answer.  1.02. What is the ratio of the Earning from trade(constant 2005 US) in Bulgaria in 2012 to that in 2013?
Offer a very short reply. 0.92. What is the ratio of the Earning from trade(constant 2005 US) in Greece in 2012 to that in 2013?
Ensure brevity in your answer.  0.98. What is the ratio of the Earning from trade(constant 2005 US) in Montenegro in 2012 to that in 2013?
Ensure brevity in your answer.  1.01. What is the ratio of the Earning from trade(constant 2005 US) of Bulgaria in 2012 to that in 2014?
Offer a very short reply. 0.92. What is the ratio of the Earning from trade(constant 2005 US) of Greece in 2012 to that in 2014?
Your answer should be very brief. 0.91. What is the ratio of the Earning from trade(constant 2005 US) in Montenegro in 2012 to that in 2014?
Offer a very short reply. 1.02. What is the ratio of the Earning from trade(constant 2005 US) of Bulgaria in 2013 to that in 2014?
Offer a terse response. 1. What is the ratio of the Earning from trade(constant 2005 US) in Greece in 2013 to that in 2014?
Your response must be concise. 0.93. What is the ratio of the Earning from trade(constant 2005 US) in Montenegro in 2013 to that in 2014?
Make the answer very short. 1.01. What is the difference between the highest and the second highest Earning from trade(constant 2005 US) of Bulgaria?
Give a very brief answer. 2.37e+07. What is the difference between the highest and the second highest Earning from trade(constant 2005 US) in Greece?
Ensure brevity in your answer.  2.13e+09. What is the difference between the highest and the second highest Earning from trade(constant 2005 US) in Montenegro?
Your answer should be compact. 2.61e+07. What is the difference between the highest and the lowest Earning from trade(constant 2005 US) in Bulgaria?
Provide a short and direct response. 6.48e+09. What is the difference between the highest and the lowest Earning from trade(constant 2005 US) in Greece?
Ensure brevity in your answer.  1.18e+1. What is the difference between the highest and the lowest Earning from trade(constant 2005 US) of Montenegro?
Your answer should be very brief. 3.05e+08. 